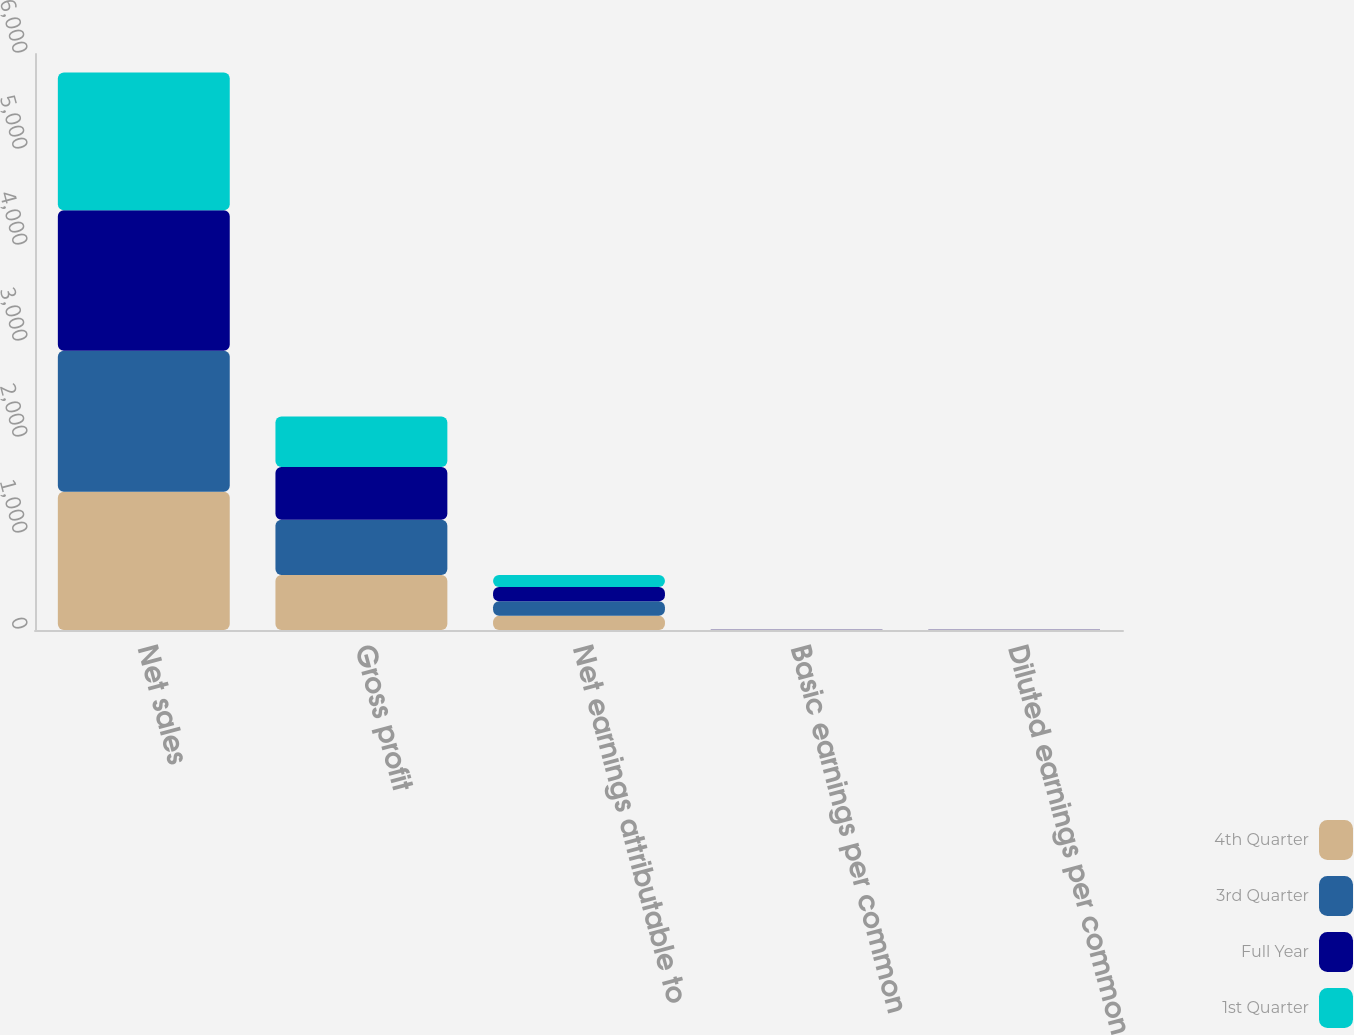<chart> <loc_0><loc_0><loc_500><loc_500><stacked_bar_chart><ecel><fcel>Net sales<fcel>Gross profit<fcel>Net earnings attributable to<fcel>Basic earnings per common<fcel>Diluted earnings per common<nl><fcel>4th Quarter<fcel>1440.9<fcel>572.2<fcel>147.2<fcel>1.58<fcel>1.56<nl><fcel>3rd Quarter<fcel>1468.2<fcel>577.3<fcel>151.9<fcel>1.65<fcel>1.62<nl><fcel>Full Year<fcel>1462.2<fcel>547.6<fcel>148.3<fcel>1.66<fcel>1.63<nl><fcel>1st Quarter<fcel>1437<fcel>526.1<fcel>126.4<fcel>1.46<fcel>1.43<nl></chart> 